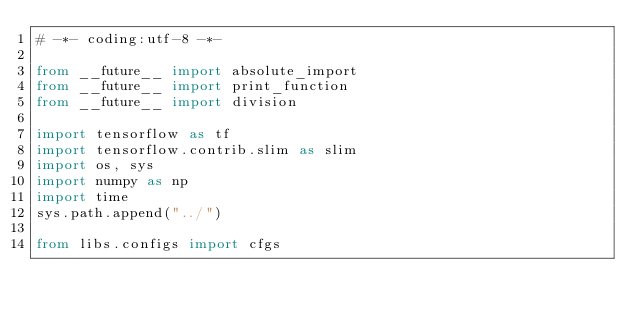Convert code to text. <code><loc_0><loc_0><loc_500><loc_500><_Python_># -*- coding:utf-8 -*-

from __future__ import absolute_import
from __future__ import print_function
from __future__ import division

import tensorflow as tf
import tensorflow.contrib.slim as slim
import os, sys
import numpy as np
import time
sys.path.append("../")

from libs.configs import cfgs</code> 